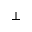<formula> <loc_0><loc_0><loc_500><loc_500>\perp</formula> 